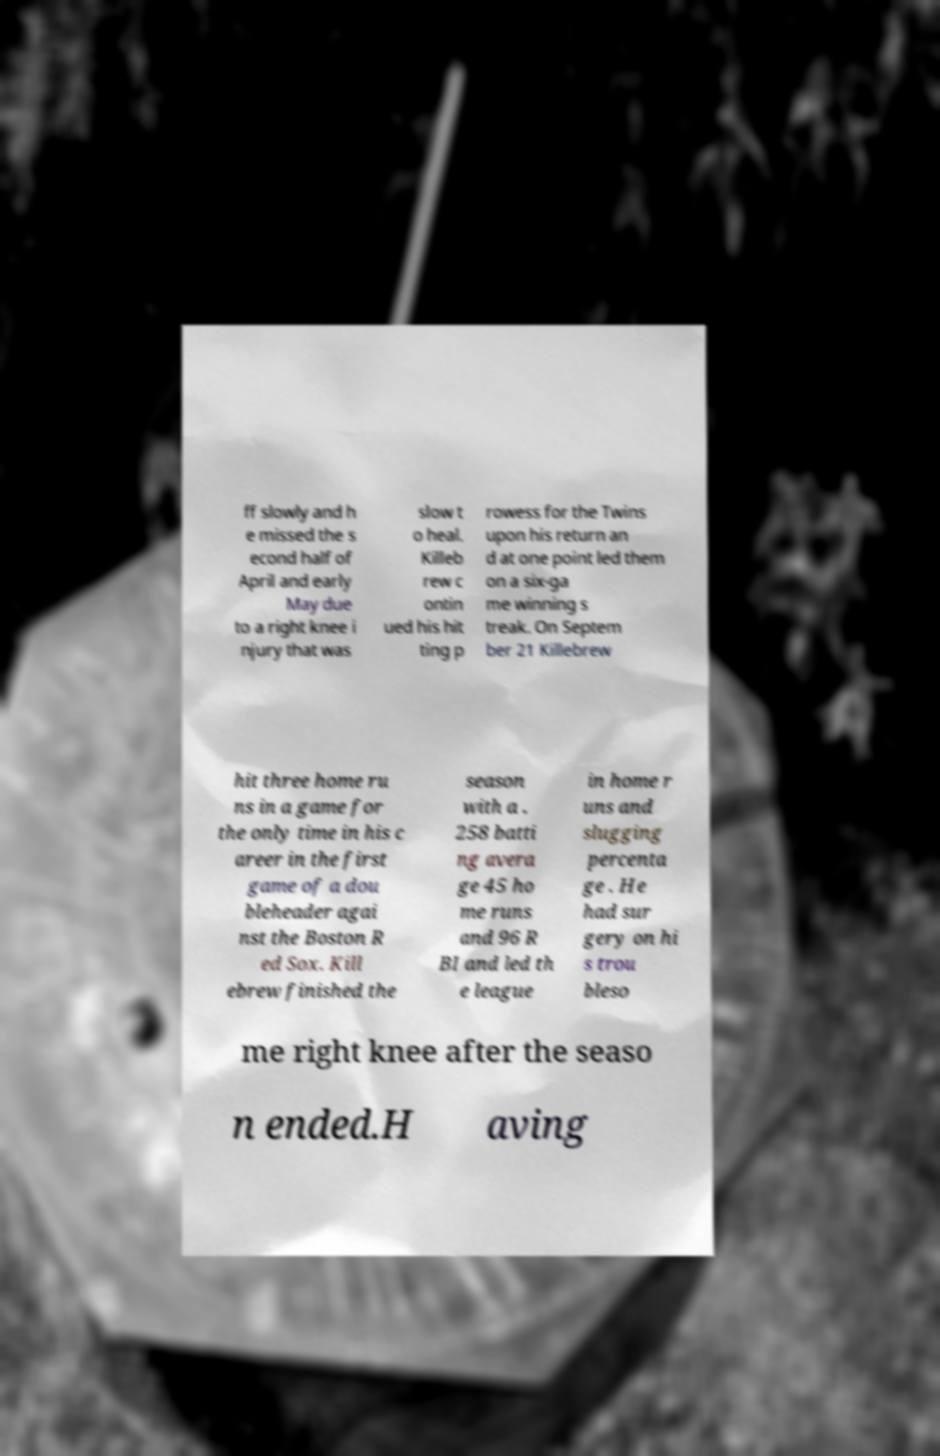Can you accurately transcribe the text from the provided image for me? ff slowly and h e missed the s econd half of April and early May due to a right knee i njury that was slow t o heal. Killeb rew c ontin ued his hit ting p rowess for the Twins upon his return an d at one point led them on a six-ga me winning s treak. On Septem ber 21 Killebrew hit three home ru ns in a game for the only time in his c areer in the first game of a dou bleheader agai nst the Boston R ed Sox. Kill ebrew finished the season with a . 258 batti ng avera ge 45 ho me runs and 96 R BI and led th e league in home r uns and slugging percenta ge . He had sur gery on hi s trou bleso me right knee after the seaso n ended.H aving 